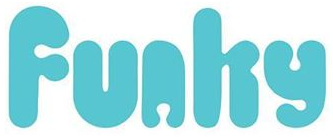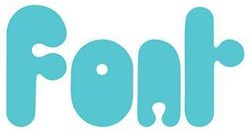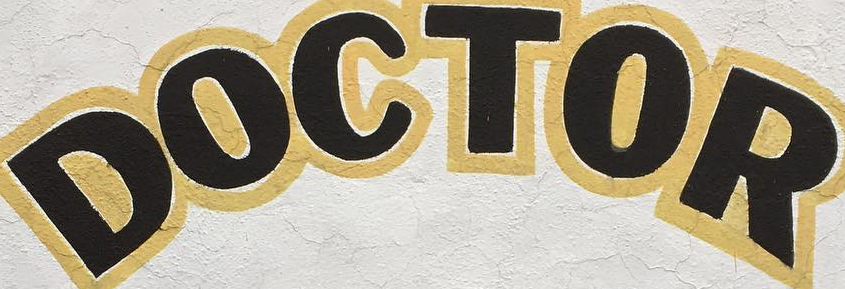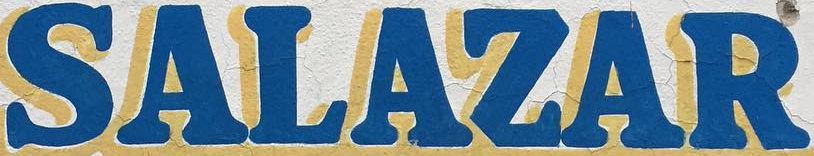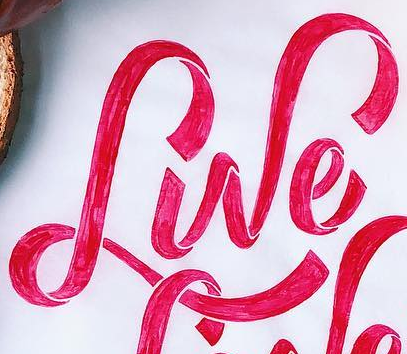Read the text content from these images in order, separated by a semicolon. Funhy; Fonr; DOCTOR; SALAZAR; Lwe 